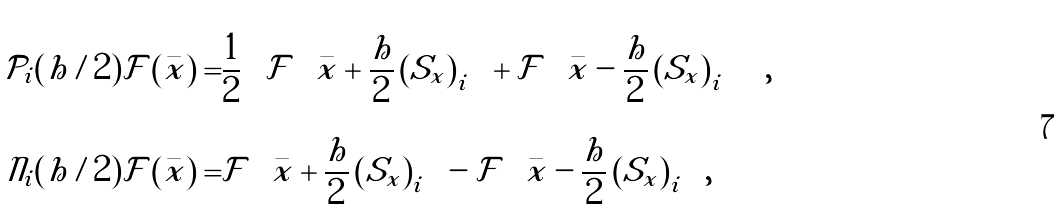Convert formula to latex. <formula><loc_0><loc_0><loc_500><loc_500>\mathcal { P } _ { i } ( h / 2 ) \mathcal { F } \left ( \bar { x } \right ) = & \frac { 1 } { 2 } \left ( \mathcal { F } \left ( \bar { x } + \frac { h } { 2 } \left ( S _ { x } \right ) _ { i } \right ) + \mathcal { F } \left ( \bar { x } - \frac { h } { 2 } \left ( S _ { x } \right ) _ { i } \right ) \right ) , \\ \mathcal { N } _ { i } ( h / 2 ) \mathcal { F } \left ( \bar { x } \right ) = & \mathcal { F } \left ( \bar { x } + \frac { h } { 2 } \left ( S _ { x } \right ) _ { i } \right ) - \mathcal { F } \left ( \bar { x } - \frac { h } { 2 } \left ( S _ { x } \right ) _ { i } \right ) ,</formula> 